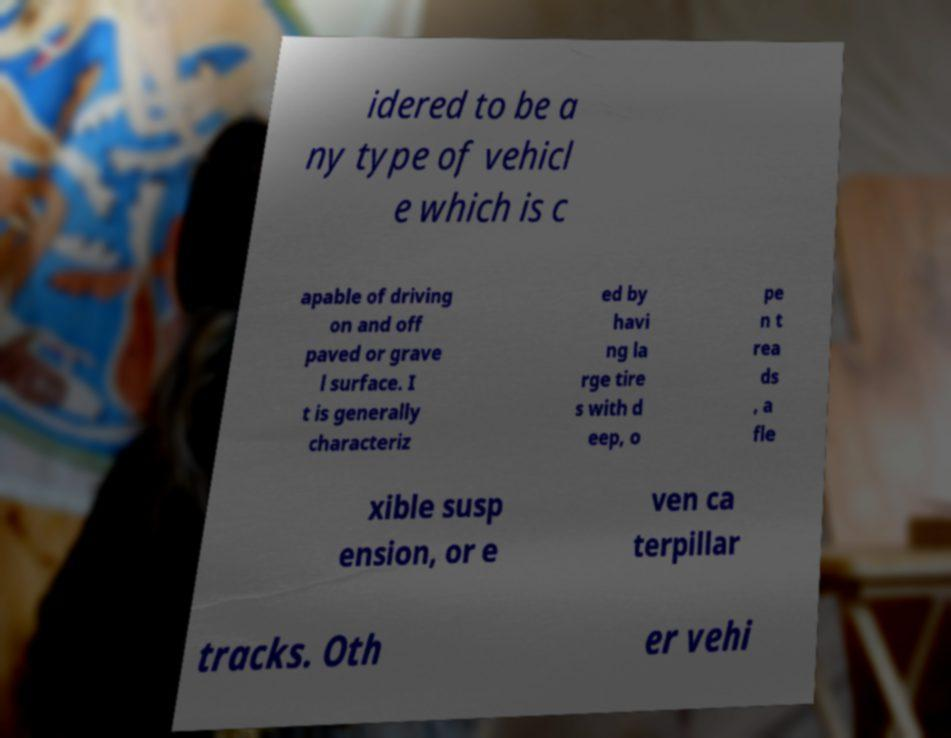There's text embedded in this image that I need extracted. Can you transcribe it verbatim? idered to be a ny type of vehicl e which is c apable of driving on and off paved or grave l surface. I t is generally characteriz ed by havi ng la rge tire s with d eep, o pe n t rea ds , a fle xible susp ension, or e ven ca terpillar tracks. Oth er vehi 